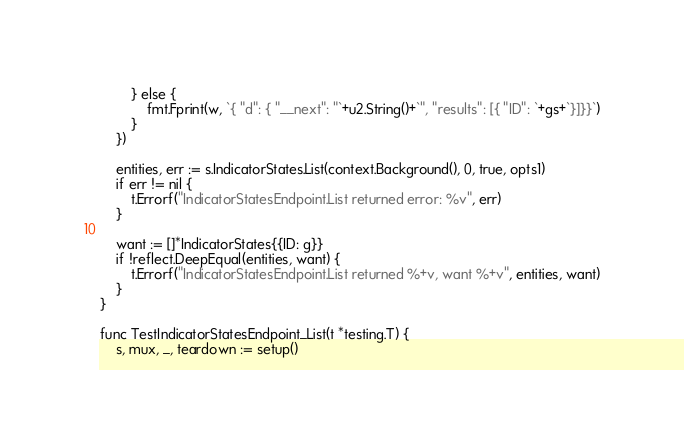Convert code to text. <code><loc_0><loc_0><loc_500><loc_500><_Go_>		} else {
			fmt.Fprint(w, `{ "d": { "__next": "`+u2.String()+`", "results": [{ "ID": `+gs+`}]}}`)
		}
	})

	entities, err := s.IndicatorStates.List(context.Background(), 0, true, opts1)
	if err != nil {
		t.Errorf("IndicatorStatesEndpoint.List returned error: %v", err)
	}

	want := []*IndicatorStates{{ID: g}}
	if !reflect.DeepEqual(entities, want) {
		t.Errorf("IndicatorStatesEndpoint.List returned %+v, want %+v", entities, want)
	}
}

func TestIndicatorStatesEndpoint_List(t *testing.T) {
	s, mux, _, teardown := setup()</code> 